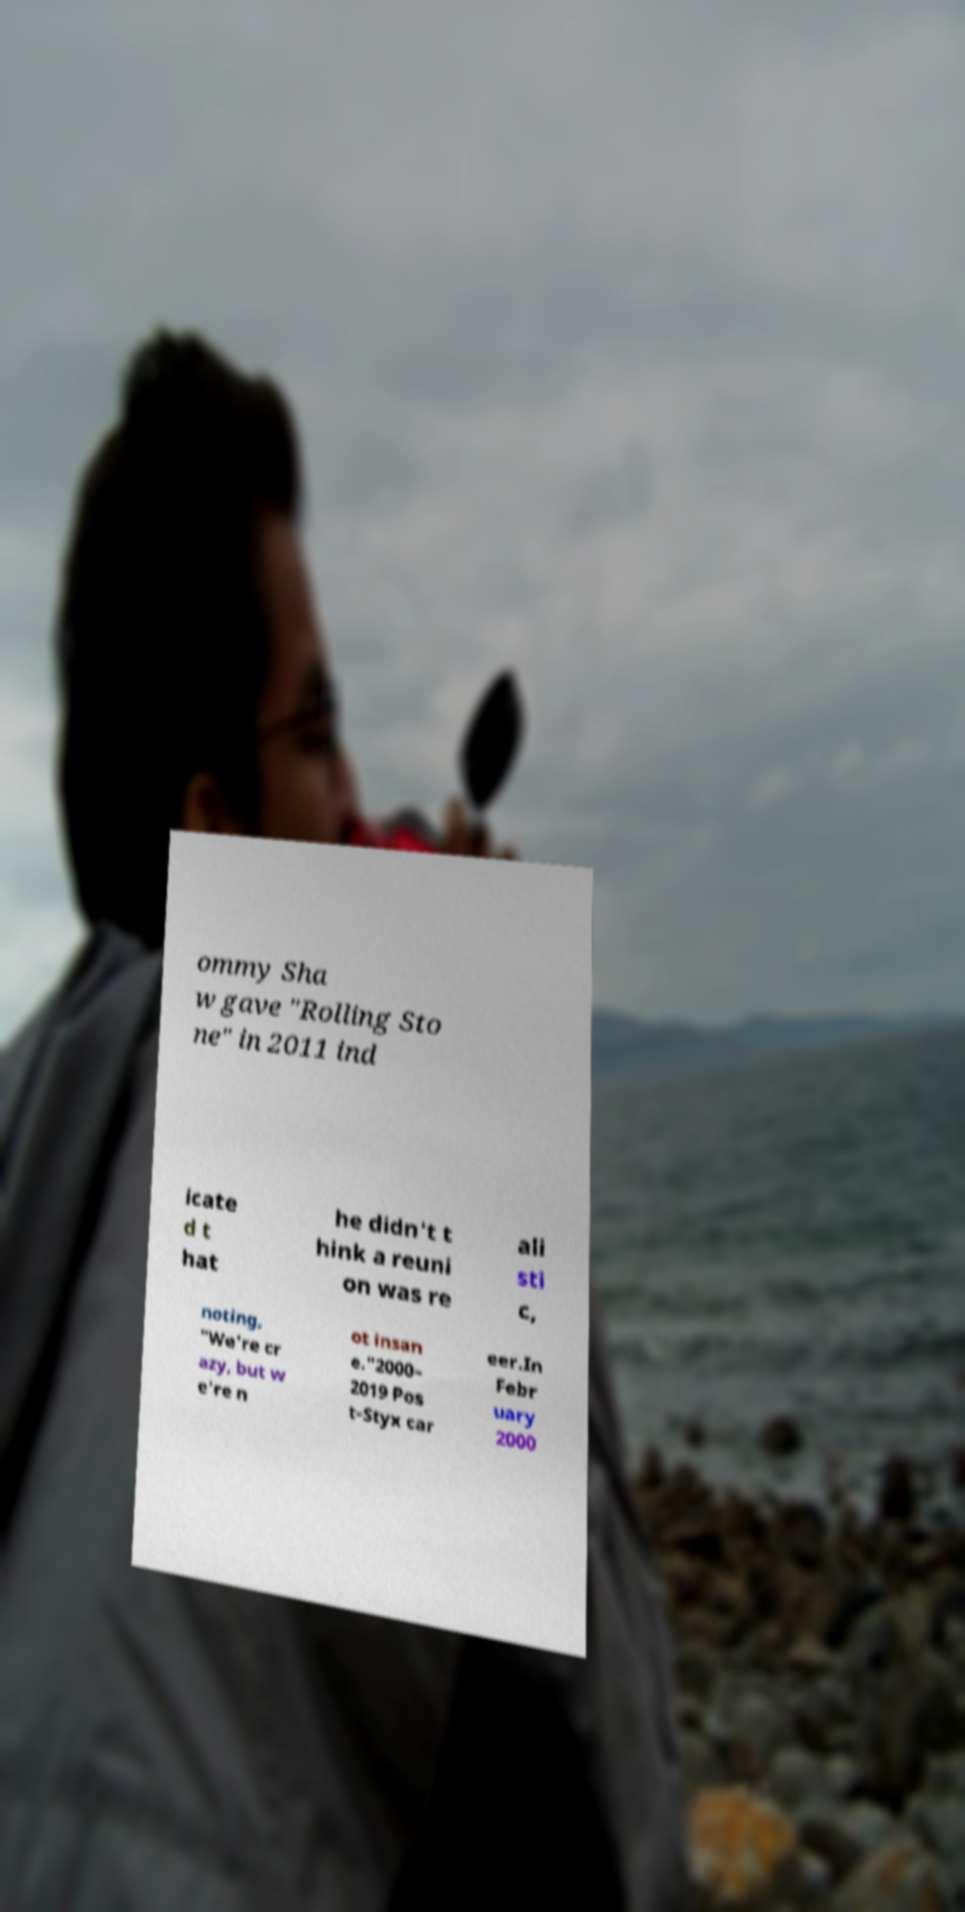Can you accurately transcribe the text from the provided image for me? ommy Sha w gave "Rolling Sto ne" in 2011 ind icate d t hat he didn't t hink a reuni on was re ali sti c, noting, "We're cr azy, but w e're n ot insan e."2000– 2019 Pos t-Styx car eer.In Febr uary 2000 